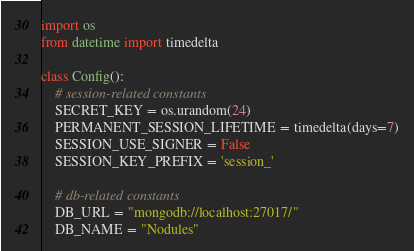<code> <loc_0><loc_0><loc_500><loc_500><_Python_>import os
from datetime import timedelta

class Config():
    # session-related constants
    SECRET_KEY = os.urandom(24)
    PERMANENT_SESSION_LIFETIME = timedelta(days=7)
    SESSION_USE_SIGNER = False
    SESSION_KEY_PREFIX = 'session_'

    # db-related constants
    DB_URL = "mongodb://localhost:27017/"
    DB_NAME = "Nodules"</code> 